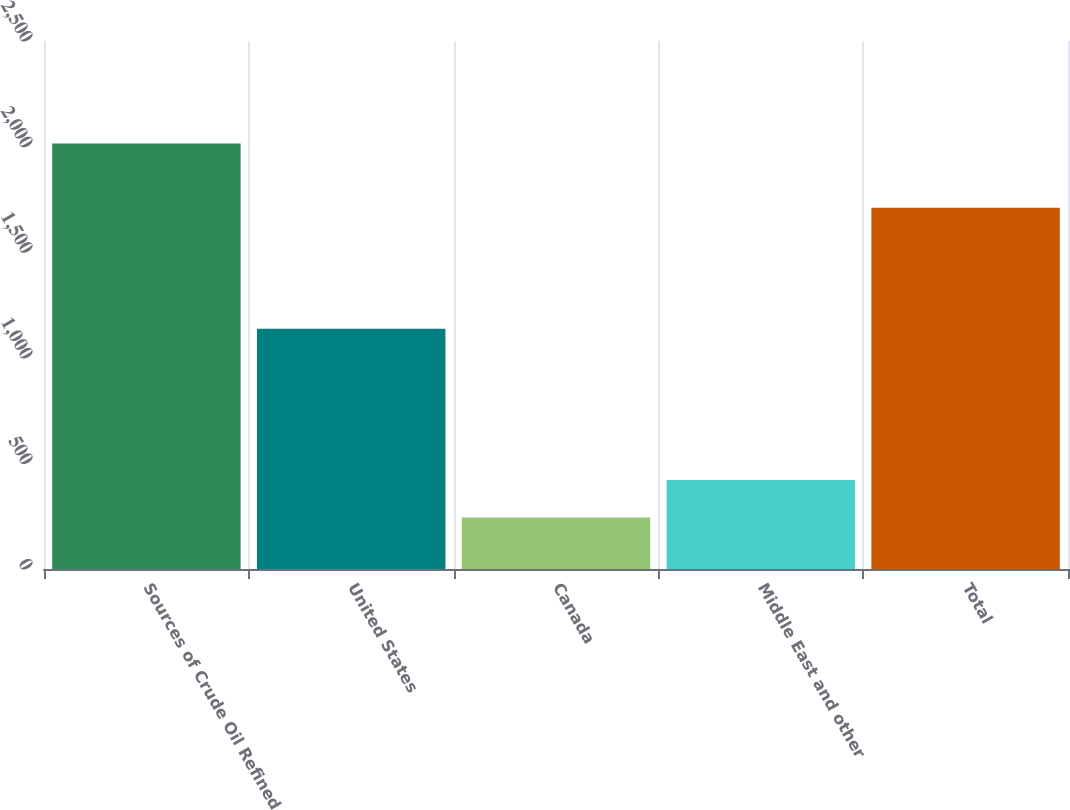Convert chart. <chart><loc_0><loc_0><loc_500><loc_500><bar_chart><fcel>Sources of Crude Oil Refined<fcel>United States<fcel>Canada<fcel>Middle East and other<fcel>Total<nl><fcel>2015<fcel>1138<fcel>244<fcel>421.1<fcel>1711<nl></chart> 